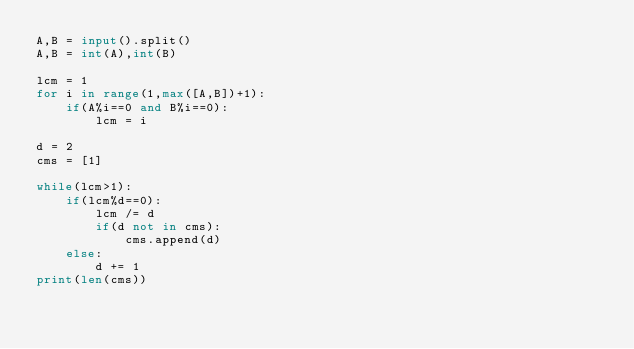<code> <loc_0><loc_0><loc_500><loc_500><_Python_>A,B = input().split()
A,B = int(A),int(B)

lcm = 1
for i in range(1,max([A,B])+1):
    if(A%i==0 and B%i==0):
        lcm = i

d = 2
cms = [1]

while(lcm>1):
    if(lcm%d==0):
        lcm /= d
        if(d not in cms):
            cms.append(d)
    else:
        d += 1
print(len(cms))</code> 